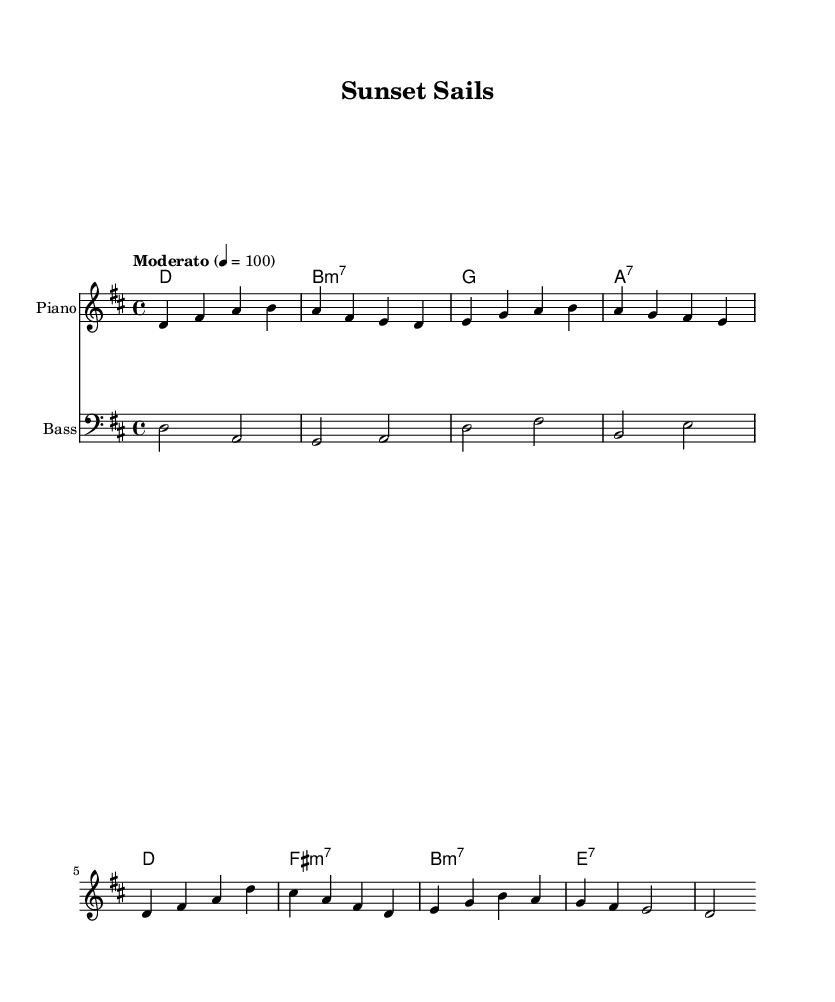What is the key signature of this music? The key signature is indicated at the beginning of the staff. It has two sharps, which corresponds to D major.
Answer: D major What is the time signature of this piece? The time signature is shown at the beginning of the score as 4/4, indicating four beats per measure.
Answer: 4/4 What is the tempo marking for this composition? The tempo is marked "Moderato" with a metronome marking of 100 beats per minute, indicating the speed.
Answer: Moderato What is the type of the first chord in the harmony? The first chord is noted as D major, which is presented at the start of the harmony section. It is a major chord.
Answer: D How many measures are there in the melody? The melody consists of four measures, which can be counted by the number of bars indicated in the score.
Answer: 4 What kind of bass instrument is used in this score? The score indicates the instrument using the label "Bass" and specifies the midi instrument as "acoustic bass."
Answer: Acoustic bass What seventh chords are used in the harmony section? The harmony section includes a B minor seventh chord and an A seventh chord, identifiable by the chord notations.
Answer: B minor seventh and A seventh 